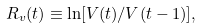Convert formula to latex. <formula><loc_0><loc_0><loc_500><loc_500>R _ { v } ( t ) \equiv \ln [ V ( t ) / V ( t - 1 ) ] ,</formula> 